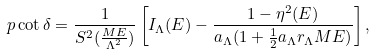<formula> <loc_0><loc_0><loc_500><loc_500>p \cot \delta = \frac { 1 } { S ^ { 2 } ( \frac { M E } { \Lambda ^ { 2 } } ) } \left [ I _ { \Lambda } ( E ) - \frac { 1 - \eta ^ { 2 } ( E ) } { a _ { \Lambda } ( 1 + \frac { 1 } { 2 } a _ { \Lambda } r _ { \Lambda } M E ) } \right ] ,</formula> 